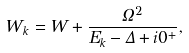<formula> <loc_0><loc_0><loc_500><loc_500>W _ { k } = W + \frac { \Omega ^ { 2 } } { E _ { k } - \Delta + i 0 ^ { + } } ,</formula> 